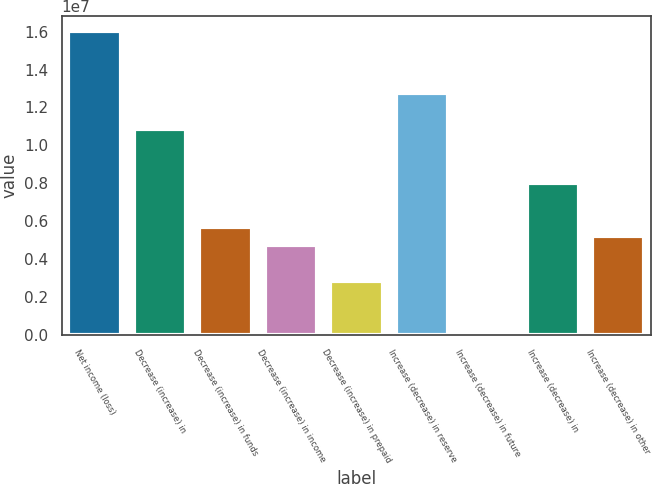<chart> <loc_0><loc_0><loc_500><loc_500><bar_chart><fcel>Net income (loss)<fcel>Decrease (increase) in<fcel>Decrease (increase) in funds<fcel>Decrease (increase) in income<fcel>Decrease (increase) in prepaid<fcel>Increase (decrease) in reserve<fcel>Increase (decrease) in future<fcel>Increase (decrease) in<fcel>Increase (decrease) in other<nl><fcel>1.604e+07<fcel>1.08509e+07<fcel>5.66178e+06<fcel>4.7183e+06<fcel>2.83135e+06<fcel>1.27379e+07<fcel>910<fcel>8.02048e+06<fcel>5.19004e+06<nl></chart> 